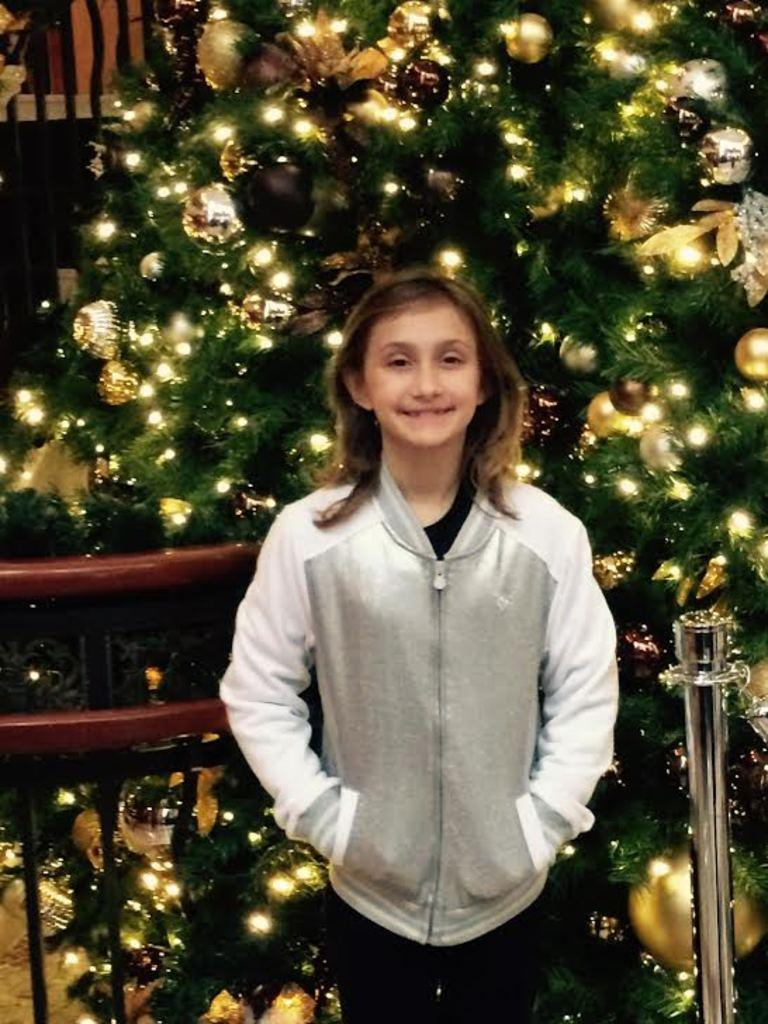Who is present in the image? There is a girl in the image. What is the girl's expression? The girl is smiling. What can be seen in the background of the image? There is a tree with decoration in the image. What objects can be seen in the image that are not related to the girl or the tree? There is a rod and a railing in the image. What type of carriage is being pulled by the horse in the image? There is no horse or carriage present in the image. Is the girl holding a rifle in the image? No, the girl is not holding a rifle in the image. 